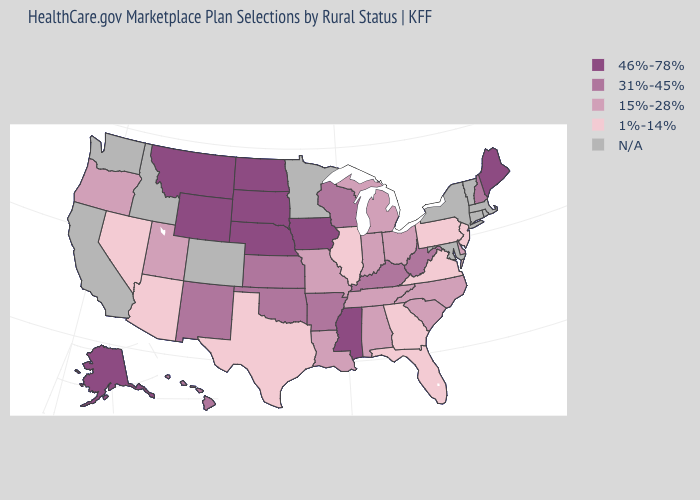Which states have the lowest value in the USA?
Give a very brief answer. Arizona, Florida, Georgia, Illinois, Nevada, New Jersey, Pennsylvania, Texas, Virginia. Name the states that have a value in the range N/A?
Keep it brief. California, Colorado, Connecticut, Idaho, Maryland, Massachusetts, Minnesota, New York, Rhode Island, Vermont, Washington. What is the highest value in the USA?
Be succinct. 46%-78%. What is the value of Illinois?
Write a very short answer. 1%-14%. What is the value of Virginia?
Short answer required. 1%-14%. What is the highest value in the USA?
Give a very brief answer. 46%-78%. How many symbols are there in the legend?
Short answer required. 5. Name the states that have a value in the range N/A?
Keep it brief. California, Colorado, Connecticut, Idaho, Maryland, Massachusetts, Minnesota, New York, Rhode Island, Vermont, Washington. Name the states that have a value in the range N/A?
Write a very short answer. California, Colorado, Connecticut, Idaho, Maryland, Massachusetts, Minnesota, New York, Rhode Island, Vermont, Washington. Which states have the highest value in the USA?
Short answer required. Alaska, Iowa, Maine, Mississippi, Montana, Nebraska, North Dakota, South Dakota, Wyoming. Name the states that have a value in the range 1%-14%?
Be succinct. Arizona, Florida, Georgia, Illinois, Nevada, New Jersey, Pennsylvania, Texas, Virginia. Which states have the lowest value in the USA?
Answer briefly. Arizona, Florida, Georgia, Illinois, Nevada, New Jersey, Pennsylvania, Texas, Virginia. Name the states that have a value in the range 1%-14%?
Quick response, please. Arizona, Florida, Georgia, Illinois, Nevada, New Jersey, Pennsylvania, Texas, Virginia. What is the value of Texas?
Keep it brief. 1%-14%. 